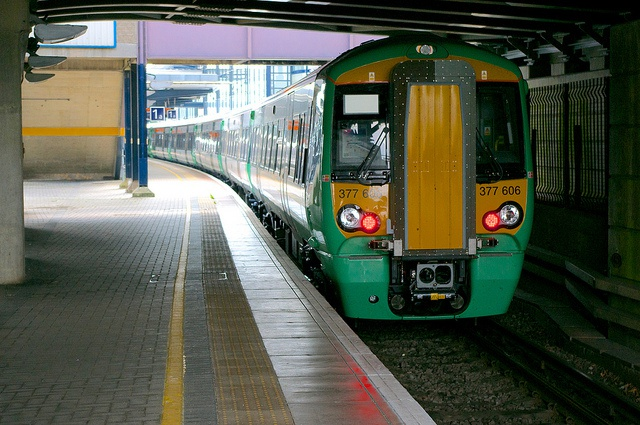Describe the objects in this image and their specific colors. I can see a train in black, olive, and darkgreen tones in this image. 